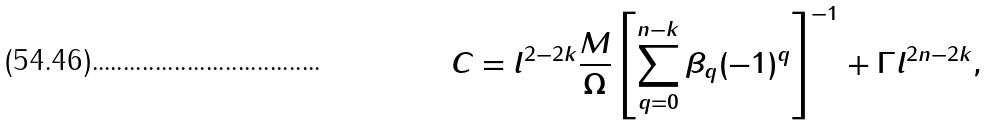Convert formula to latex. <formula><loc_0><loc_0><loc_500><loc_500>C = l ^ { 2 - 2 k } \frac { M } { \Omega } \left [ \sum _ { q = 0 } ^ { n - k } \beta _ { q } ( - 1 ) ^ { q } \right ] ^ { - 1 } + \Gamma l ^ { 2 n - 2 k } ,</formula> 